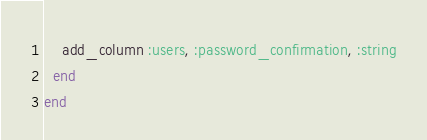Convert code to text. <code><loc_0><loc_0><loc_500><loc_500><_Ruby_>    add_column :users, :password_confirmation, :string
  end
end
</code> 